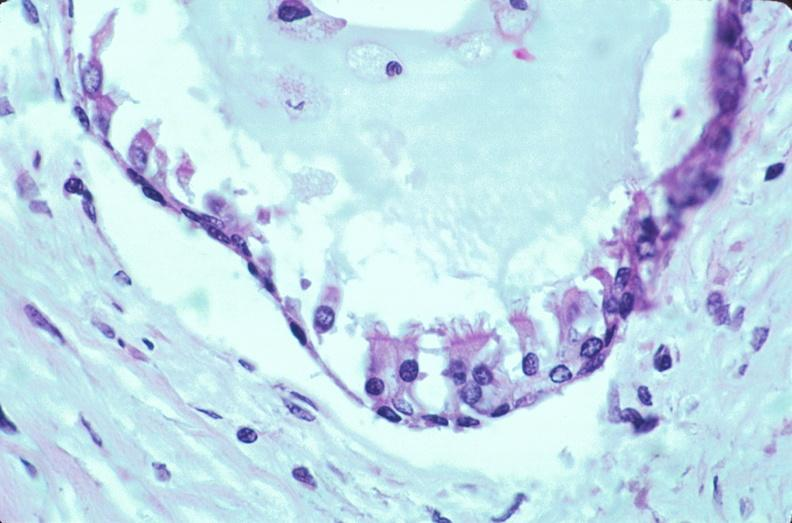s embryo-fetus present?
Answer the question using a single word or phrase. Yes 